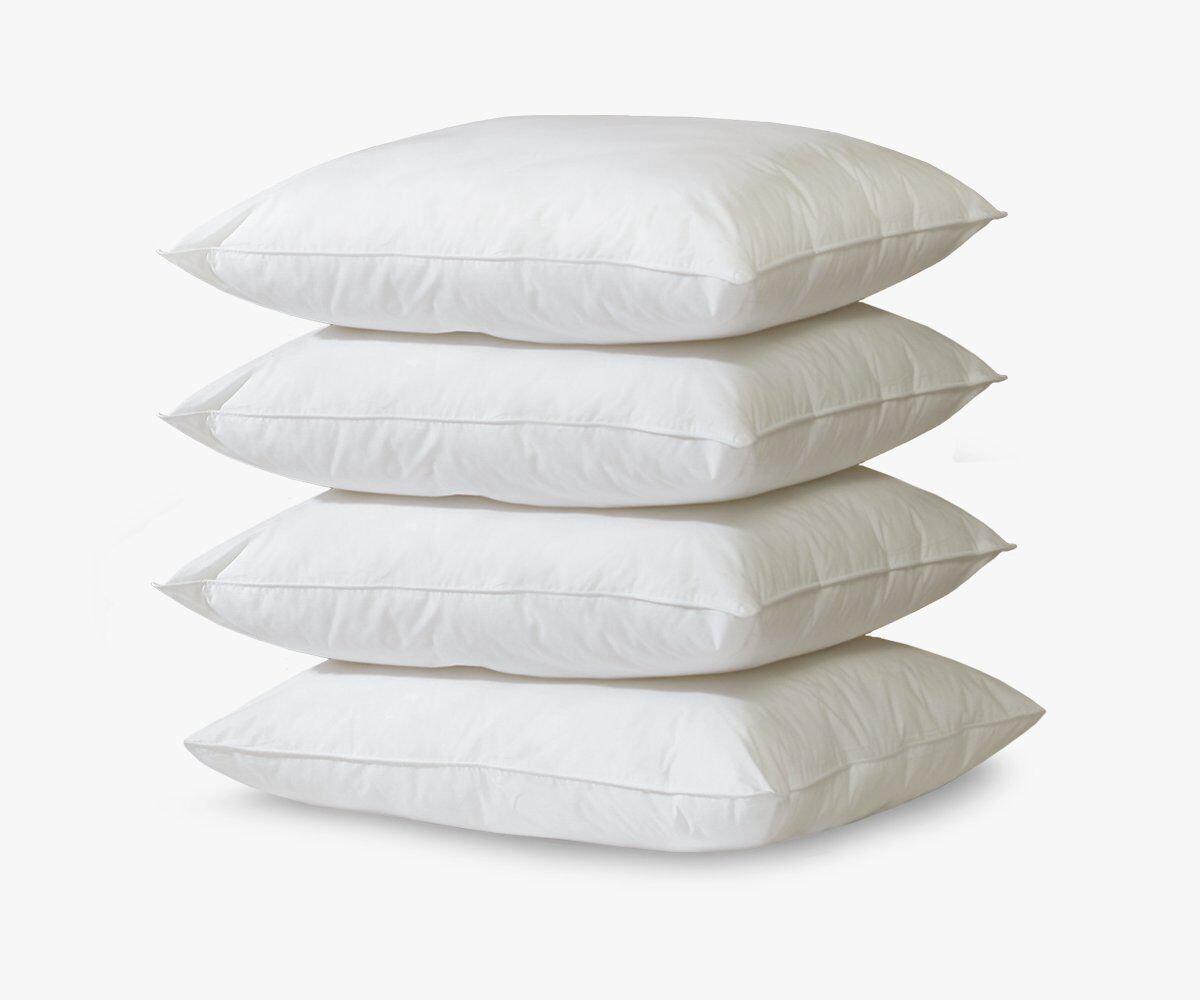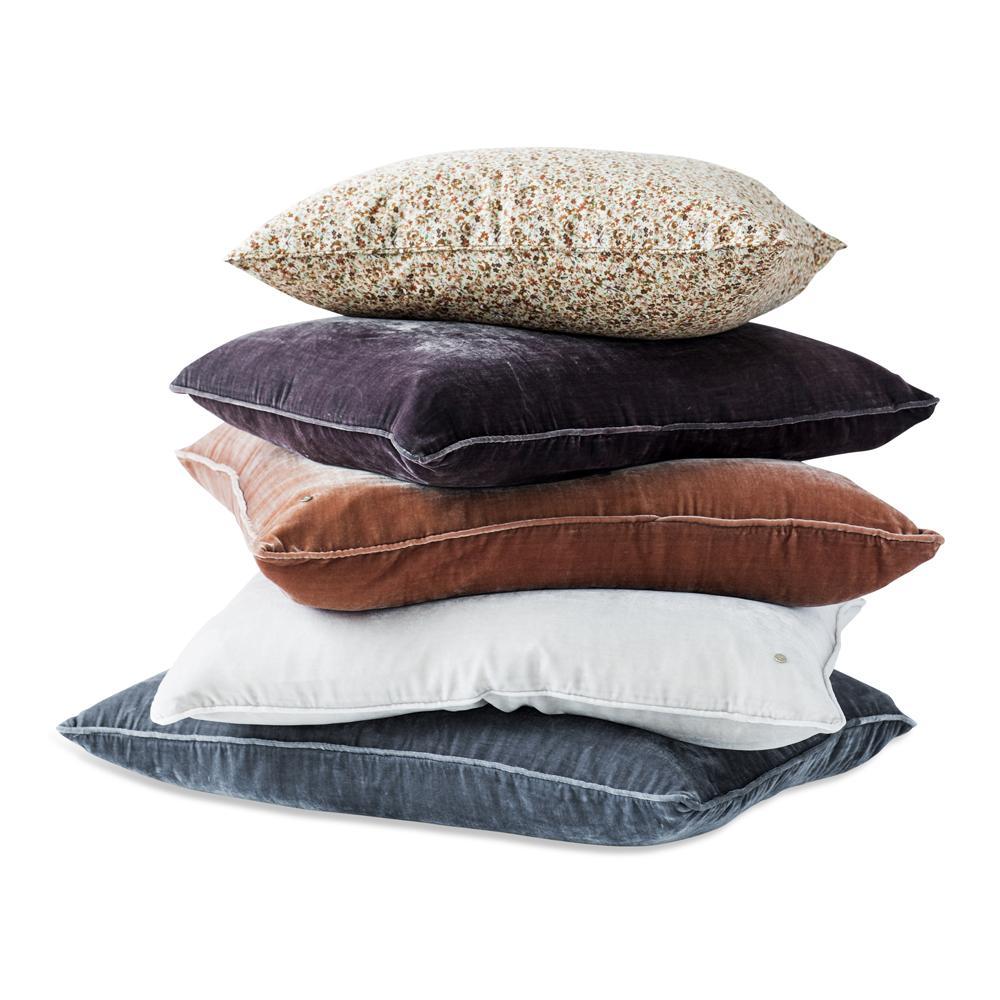The first image is the image on the left, the second image is the image on the right. Analyze the images presented: Is the assertion "The right image contains a vertical stack of at least four pillows." valid? Answer yes or no. Yes. 